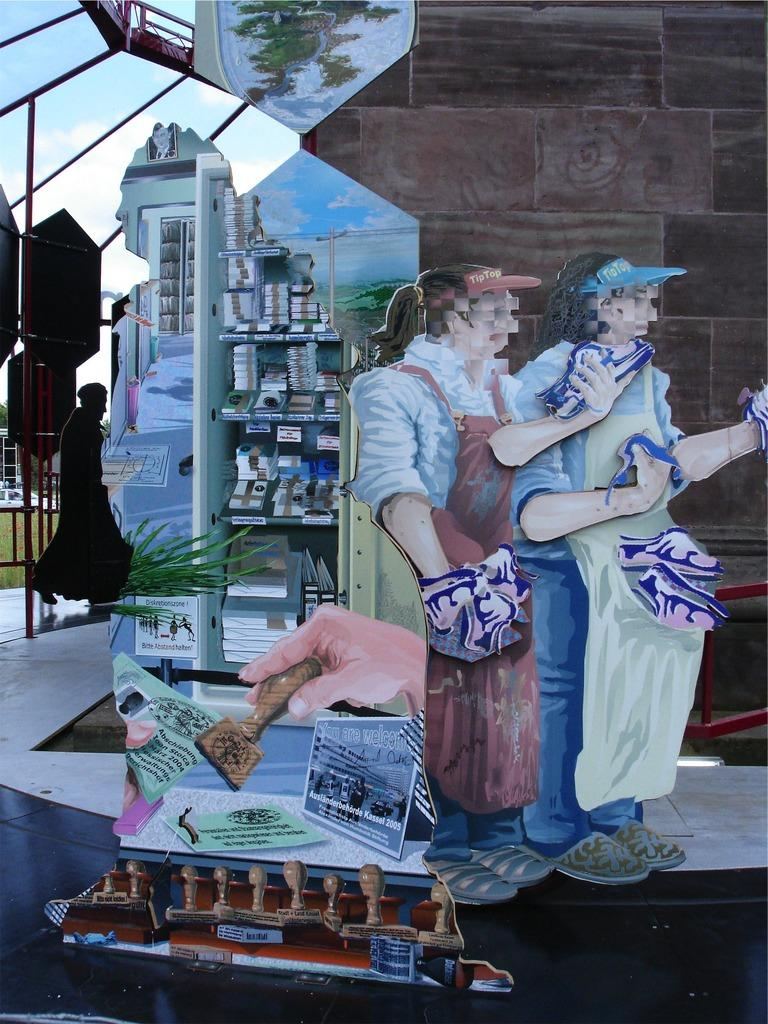What type of visual art is depicted in the image? The image contains a visual art. How many persons are present in the visual art? There are two persons in the visual art. What color is the wall on the right side of the visual art? The wall on the right side of the visual art is brown. What can be seen in the background of the visual art? There is a sky visible in the background of the visual art, with clouds present. What type of ray is swimming in the middle of the visual art? There is no ray present in the visual art; it features two persons, a brown wall, and a sky with clouds. 